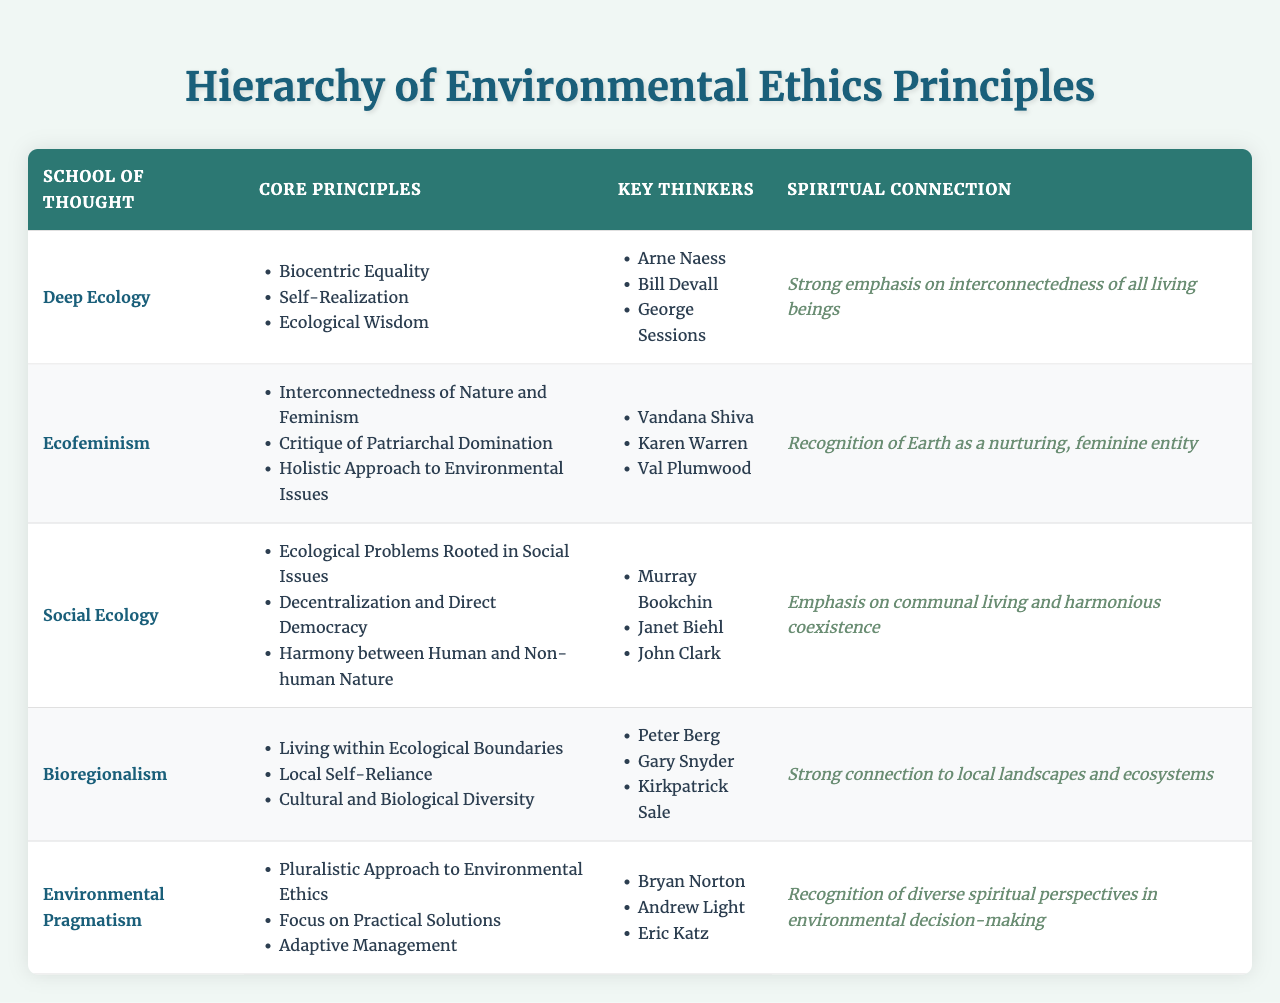What are the core principles of Ecofeminism? Ecofeminism has three core principles listed in the table: Interconnectedness of Nature and Feminism, Critique of Patriarchal Domination, and Holistic Approach to Environmental Issues.
Answer: Interconnectedness of Nature and Feminism, Critique of Patriarchal Domination, Holistic Approach to Environmental Issues Who are the key thinkers associated with Deep Ecology? The key thinkers associated with Deep Ecology, as mentioned in the table, are Arne Naess, Bill Devall, and George Sessions.
Answer: Arne Naess, Bill Devall, George Sessions Is there a strong spiritual connection in Social Ecology? The table indicates that Social Ecology emphasizes communal living and harmonious coexistence, which implies a spiritual connection to community, although it may not be labeled as "strong" compared to other schools.
Answer: Yes, but less strong compared to others Which school of thought emphasizes local self-reliance? The table shows that Bioregionalism emphasizes local self-reliance as one of its core principles.
Answer: Bioregionalism How many core principles does Environmental Pragmatism have? The table lists three core principles under Environmental Pragmatism: Pluralistic Approach to Environmental Ethics, Focus on Practical Solutions, and Adaptive Management. Therefore, it has three core principles.
Answer: Three What is the spiritual connection highlighted by Ecofeminism compared to Deep Ecology? Ecofeminism recognizes Earth as a nurturing, feminine entity, while Deep Ecology emphasizes the interconnectedness of all living beings, making the spiritual connections distinct yet both significant.
Answer: Different but both significant Which philosophical school has key thinkers that include Vandana Shiva and Karen Warren? According to the table, the philosophical school that includes Vandana Shiva and Karen Warren as key thinkers is Ecofeminism.
Answer: Ecofeminism Count the total number of unique key thinkers mentioned across all schools. By reviewing the list of key thinkers for each school of thought, the unique thinkers are: Arne Naess, Bill Devall, George Sessions, Vandana Shiva, Karen Warren, Val Plumwood, Murray Bookchin, Janet Biehl, John Clark, Peter Berg, Gary Snyder, Kirkpatrick Sale, Bryan Norton, Andrew Light, and Eric Katz. This totals to 15 unique thinkers.
Answer: 15 unique thinkers What is the common spiritual theme across Bioregionalism and Social Ecology? Both Bioregionalism and Social Ecology emphasize a strong connection to local landscapes and ecosystems, as well as communal living, which suggests a common theme of harmonious coexistence with nature.
Answer: Harmonious coexistence with nature Which school of thought has a critique of patriarchal domination as one of its principles? The table indicates that the critique of patriarchal domination is a core principle of Ecofeminism.
Answer: Ecofeminism 